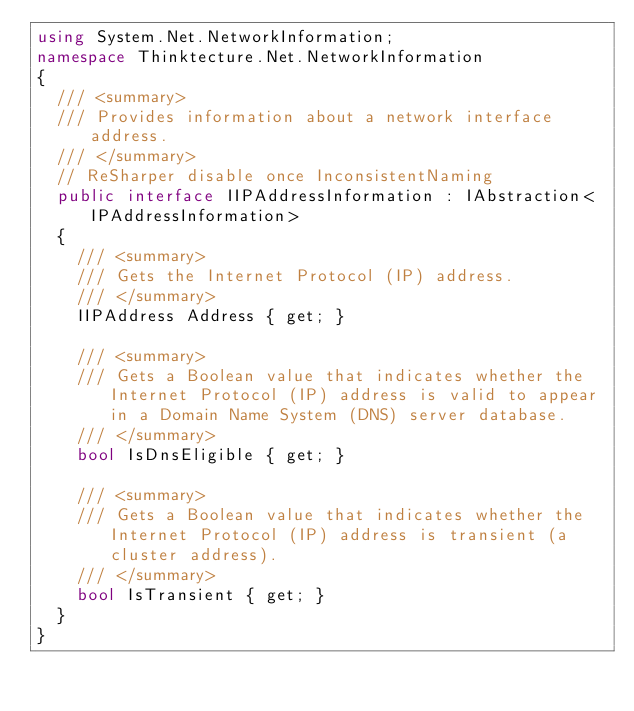Convert code to text. <code><loc_0><loc_0><loc_500><loc_500><_C#_>using System.Net.NetworkInformation;
namespace Thinktecture.Net.NetworkInformation
{
	/// <summary>
	/// Provides information about a network interface address.
	/// </summary>
	// ReSharper disable once InconsistentNaming
	public interface IIPAddressInformation : IAbstraction<IPAddressInformation>
	{
		/// <summary>
		/// Gets the Internet Protocol (IP) address.
		/// </summary>
		IIPAddress Address { get; }

		/// <summary>
		/// Gets a Boolean value that indicates whether the Internet Protocol (IP) address is valid to appear in a Domain Name System (DNS) server database.
		/// </summary>
		bool IsDnsEligible { get; }

		/// <summary>
		/// Gets a Boolean value that indicates whether the Internet Protocol (IP) address is transient (a cluster address).
		/// </summary>
		bool IsTransient { get; }
	}
}
</code> 